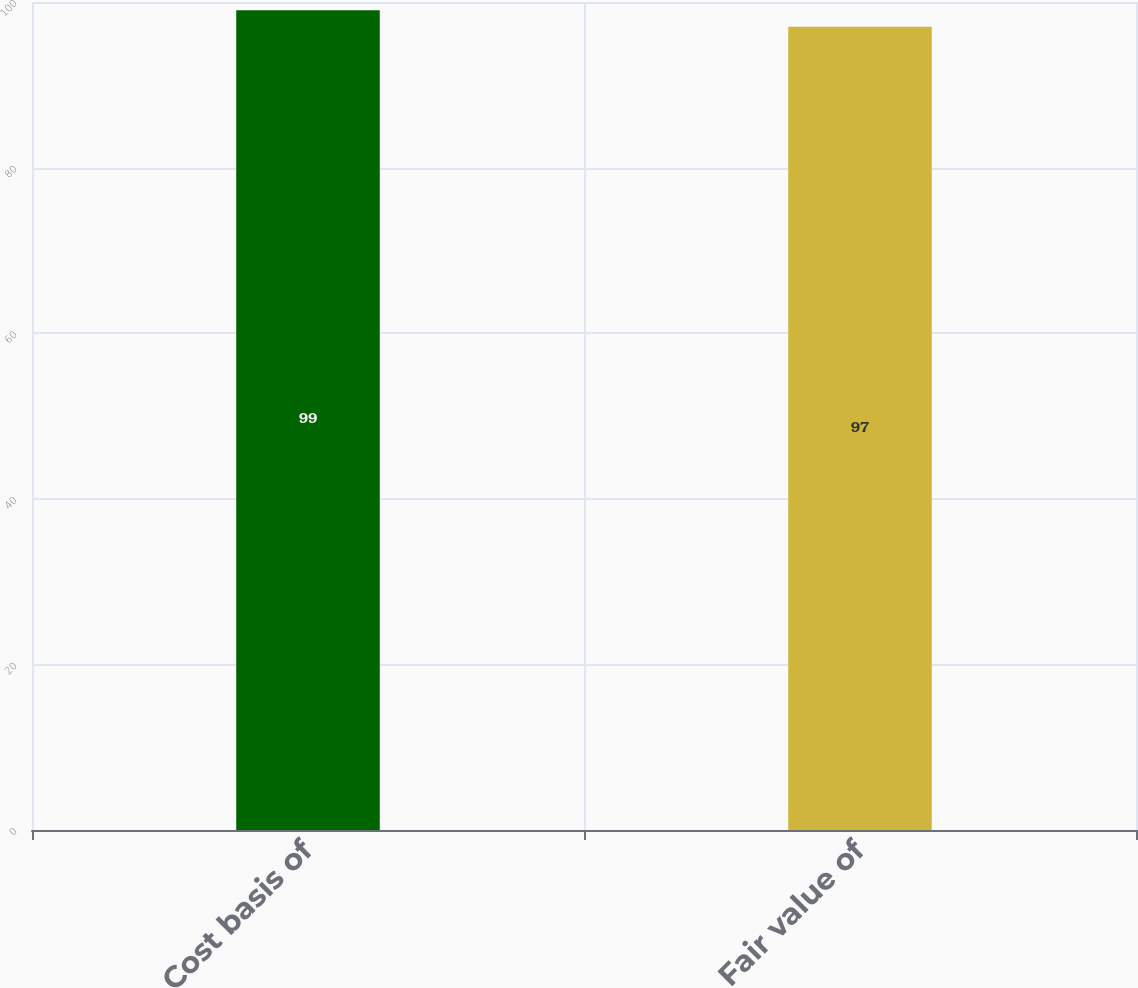Convert chart to OTSL. <chart><loc_0><loc_0><loc_500><loc_500><bar_chart><fcel>Cost basis of<fcel>Fair value of<nl><fcel>99<fcel>97<nl></chart> 